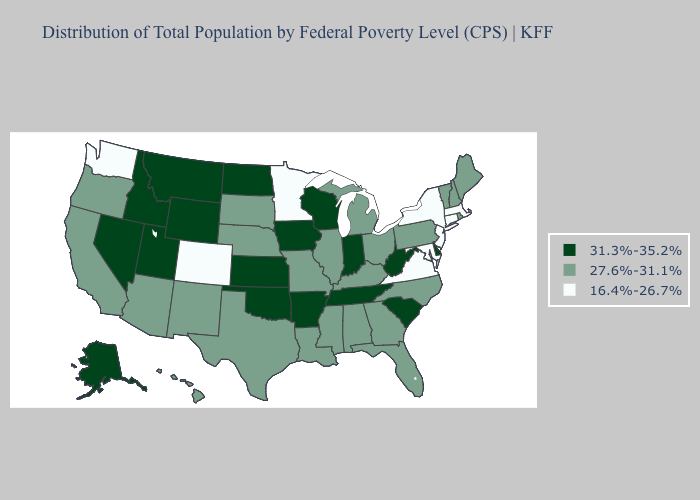Does the map have missing data?
Write a very short answer. No. Does New York have the lowest value in the Northeast?
Answer briefly. Yes. Does New Jersey have the lowest value in the Northeast?
Be succinct. Yes. Among the states that border Oregon , which have the lowest value?
Be succinct. Washington. Does Texas have a higher value than Kentucky?
Quick response, please. No. Does the map have missing data?
Write a very short answer. No. What is the value of West Virginia?
Be succinct. 31.3%-35.2%. Name the states that have a value in the range 16.4%-26.7%?
Keep it brief. Colorado, Connecticut, Maryland, Massachusetts, Minnesota, New Jersey, New York, Virginia, Washington. What is the value of Georgia?
Keep it brief. 27.6%-31.1%. Name the states that have a value in the range 16.4%-26.7%?
Keep it brief. Colorado, Connecticut, Maryland, Massachusetts, Minnesota, New Jersey, New York, Virginia, Washington. Among the states that border Kentucky , which have the lowest value?
Keep it brief. Virginia. What is the lowest value in the West?
Concise answer only. 16.4%-26.7%. Does Nebraska have the highest value in the MidWest?
Give a very brief answer. No. Does Massachusetts have the lowest value in the USA?
Short answer required. Yes. Does Nevada have the highest value in the USA?
Be succinct. Yes. 